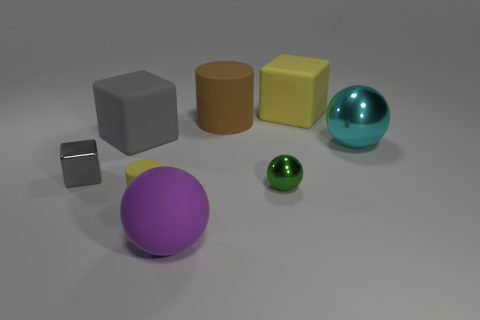Is the number of gray cubes on the right side of the large metallic ball less than the number of small spheres?
Make the answer very short. Yes. There is a yellow object in front of the big yellow matte block; what shape is it?
Offer a terse response. Cylinder. What shape is the gray rubber object that is the same size as the purple object?
Make the answer very short. Cube. Are there any gray things that have the same shape as the large brown matte object?
Keep it short and to the point. No. Is the shape of the yellow thing that is on the right side of the tiny yellow cylinder the same as the tiny object on the left side of the large gray block?
Ensure brevity in your answer.  Yes. There is a cyan thing that is the same size as the brown cylinder; what material is it?
Keep it short and to the point. Metal. How many other things are there of the same material as the large gray object?
Offer a very short reply. 4. What is the shape of the yellow matte object in front of the big ball on the right side of the brown object?
Offer a very short reply. Cylinder. How many objects are big purple matte objects or shiny spheres that are in front of the cyan thing?
Provide a short and direct response. 2. How many other objects are the same color as the small rubber object?
Provide a short and direct response. 1. 